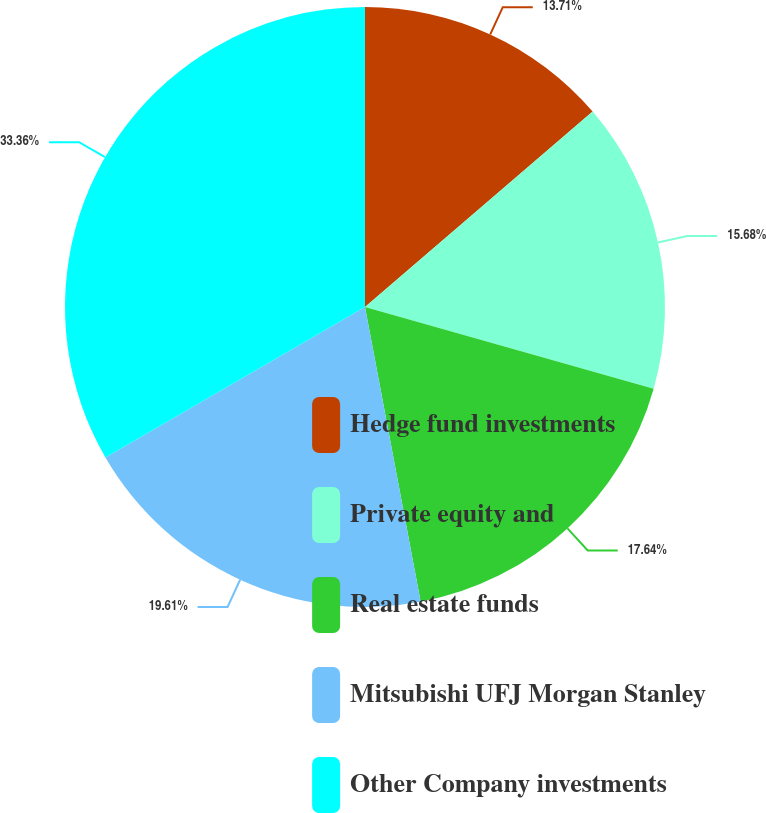<chart> <loc_0><loc_0><loc_500><loc_500><pie_chart><fcel>Hedge fund investments<fcel>Private equity and<fcel>Real estate funds<fcel>Mitsubishi UFJ Morgan Stanley<fcel>Other Company investments<nl><fcel>13.71%<fcel>15.68%<fcel>17.64%<fcel>19.61%<fcel>33.36%<nl></chart> 